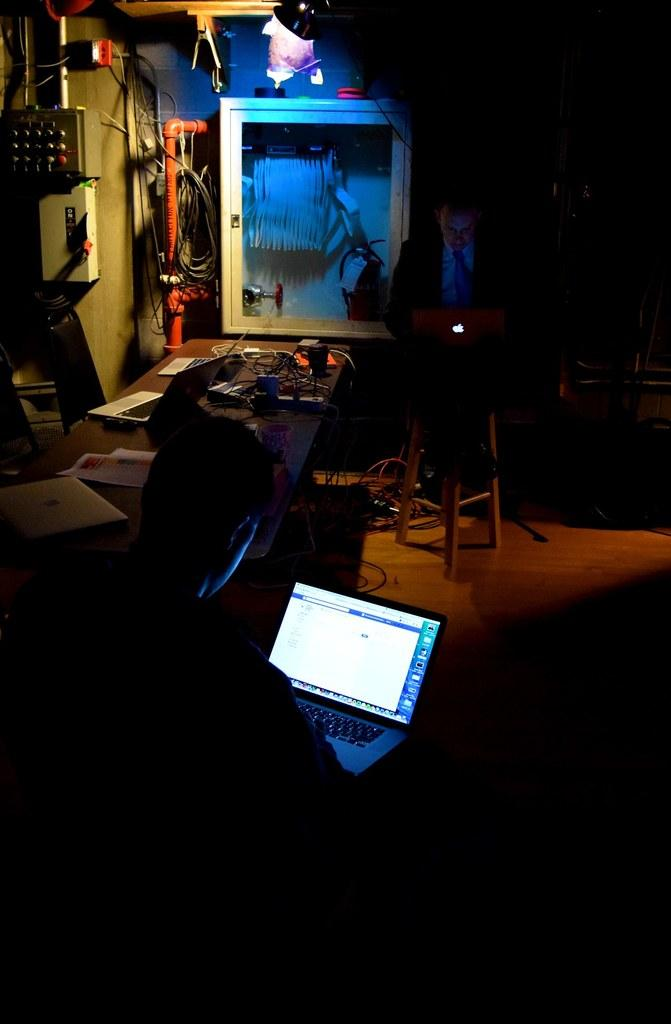What are the people in the image doing? There are two people operating laptops in the image. What is the setting of the image? There is a table with electrical stuff in the image. How many people are present in the image? There is one person present in the image. What type of ornament is hanging from the ceiling in the image? There is no ornament hanging from the ceiling in the image. What material is the copper wire used for the electrical stuff in the image? There is no mention of copper wire in the image, only that there is a table with electrical stuff. 